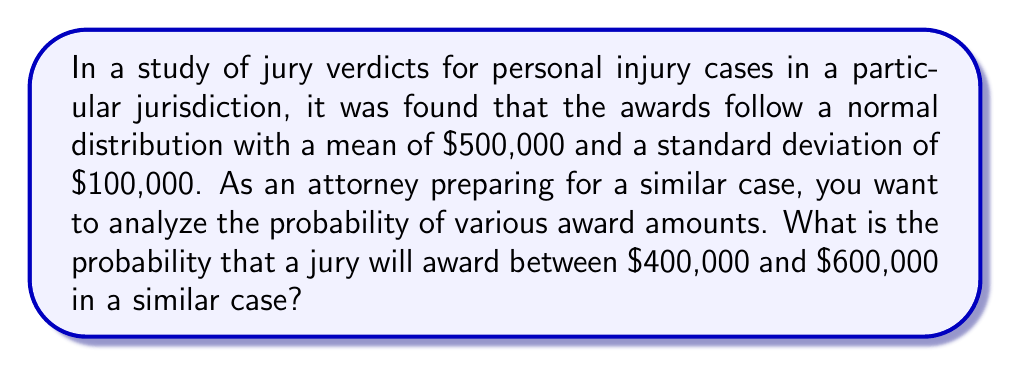Help me with this question. To solve this problem, we need to use the properties of the normal distribution and the concept of z-scores.

1. Given information:
   - The distribution is normal
   - Mean (μ) = $500,000
   - Standard deviation (σ) = $100,000
   - We want to find P($400,000 < X < $600,000)

2. Convert the dollar amounts to z-scores:
   For $400,000: $z_1 = \frac{400,000 - 500,000}{100,000} = -1$
   For $600,000: $z_2 = \frac{600,000 - 500,000}{100,000} = 1$

3. The problem now becomes finding P(-1 < Z < 1) where Z is the standard normal variable.

4. Using the standard normal distribution table or a calculator:
   P(-1 < Z < 1) = P(Z < 1) - P(Z < -1)
                 = 0.8413 - 0.1587
                 = 0.6826

5. Convert the probability to a percentage:
   0.6826 * 100 = 68.26%

Therefore, the probability that a jury will award between $400,000 and $600,000 in a similar case is approximately 68.26%.
Answer: The probability is approximately 68.26%. 